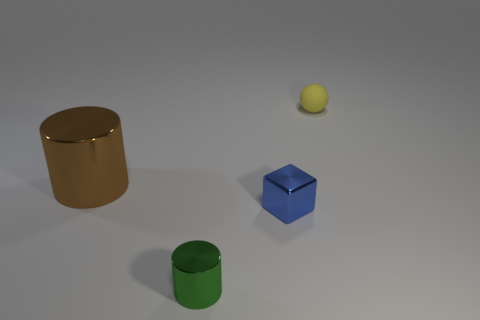What is the shape of the brown object that is made of the same material as the cube?
Keep it short and to the point. Cylinder. Are there any other things that are the same color as the tiny metallic block?
Your answer should be compact. No. What color is the shiny object on the left side of the shiny object that is in front of the tiny shiny cube?
Your answer should be compact. Brown. How many large things are yellow rubber objects or brown matte blocks?
Keep it short and to the point. 0. There is another thing that is the same shape as the large object; what is it made of?
Your response must be concise. Metal. Are there any other things that are the same material as the small blue cube?
Your answer should be very brief. Yes. The tiny metallic cube has what color?
Provide a succinct answer. Blue. Does the large cylinder have the same color as the small rubber ball?
Provide a succinct answer. No. There is a shiny cylinder that is on the right side of the brown metallic object; what number of blue objects are to the right of it?
Keep it short and to the point. 1. There is a metal thing that is to the left of the tiny blue metal thing and in front of the big brown cylinder; what is its size?
Offer a terse response. Small. 